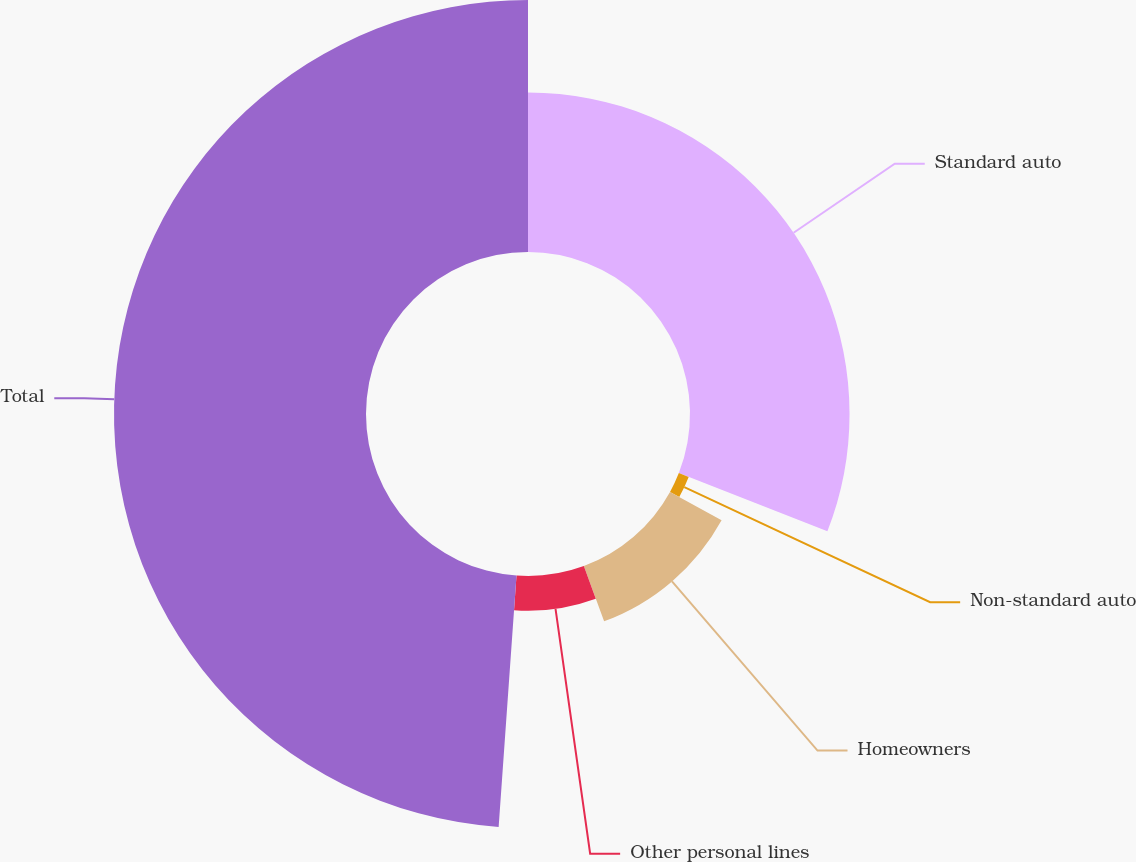<chart> <loc_0><loc_0><loc_500><loc_500><pie_chart><fcel>Standard auto<fcel>Non-standard auto<fcel>Homeowners<fcel>Other personal lines<fcel>Total<nl><fcel>30.94%<fcel>2.05%<fcel>11.41%<fcel>6.73%<fcel>48.87%<nl></chart> 